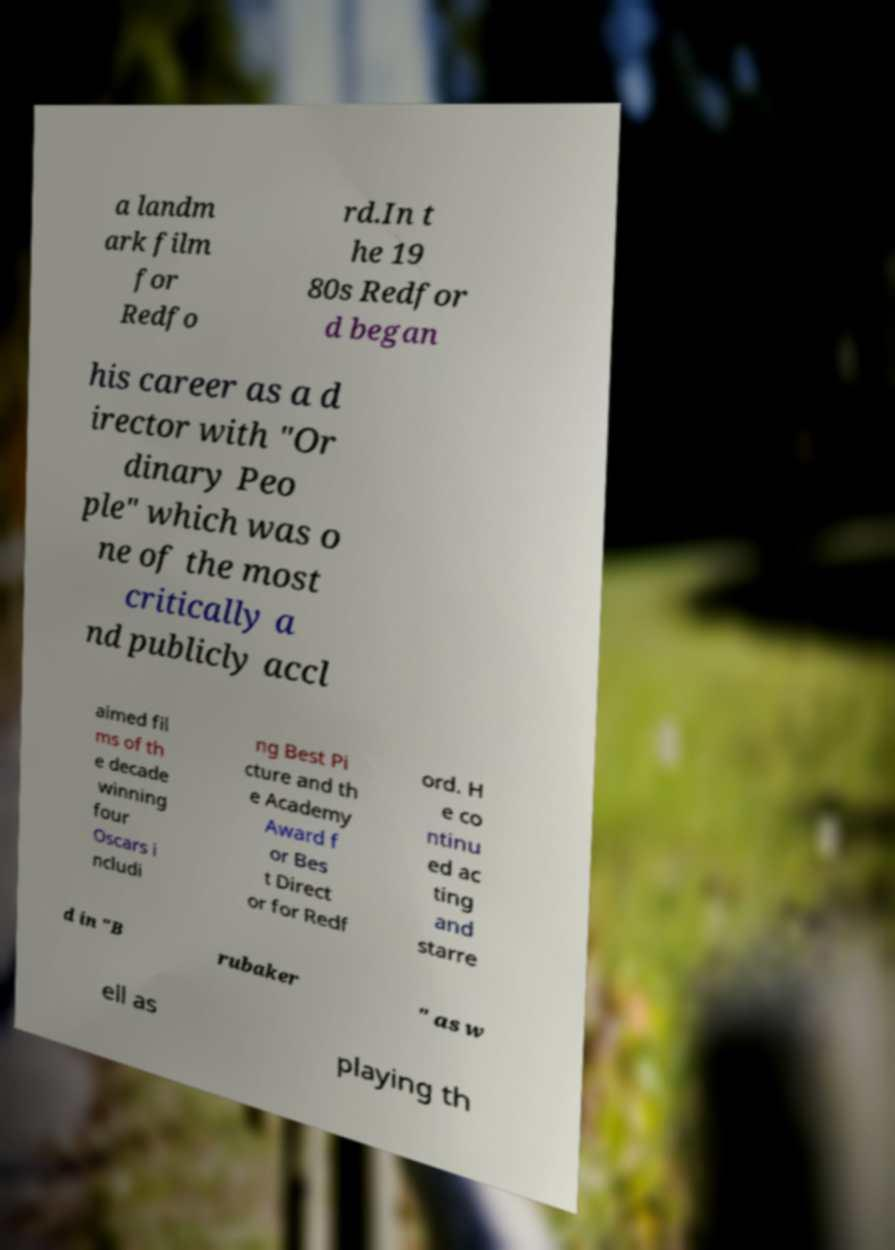For documentation purposes, I need the text within this image transcribed. Could you provide that? a landm ark film for Redfo rd.In t he 19 80s Redfor d began his career as a d irector with "Or dinary Peo ple" which was o ne of the most critically a nd publicly accl aimed fil ms of th e decade winning four Oscars i ncludi ng Best Pi cture and th e Academy Award f or Bes t Direct or for Redf ord. H e co ntinu ed ac ting and starre d in "B rubaker " as w ell as playing th 